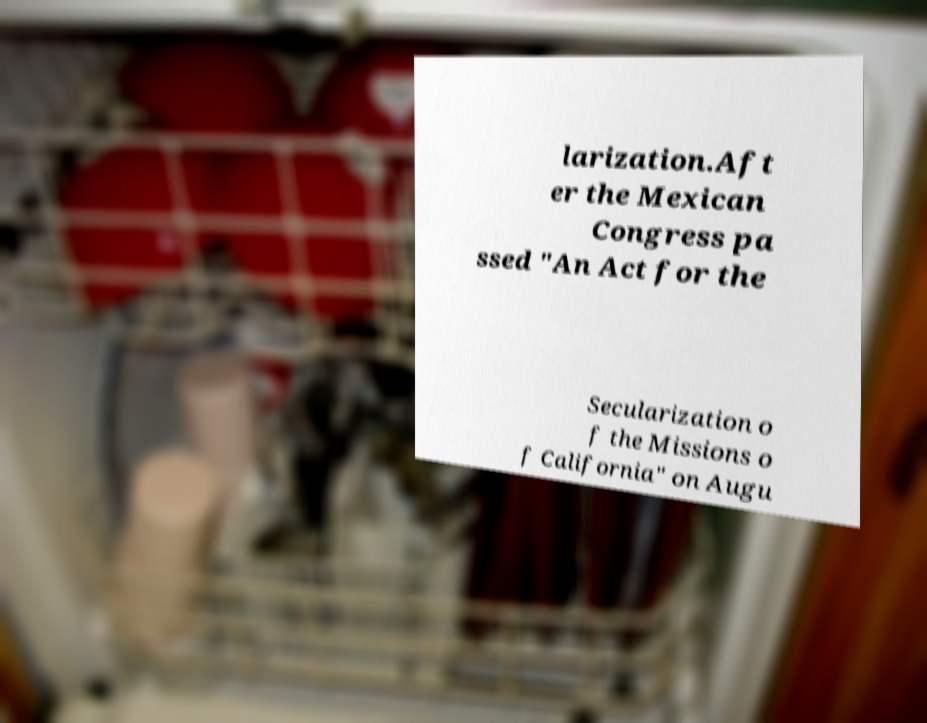Could you extract and type out the text from this image? larization.Aft er the Mexican Congress pa ssed "An Act for the Secularization o f the Missions o f California" on Augu 